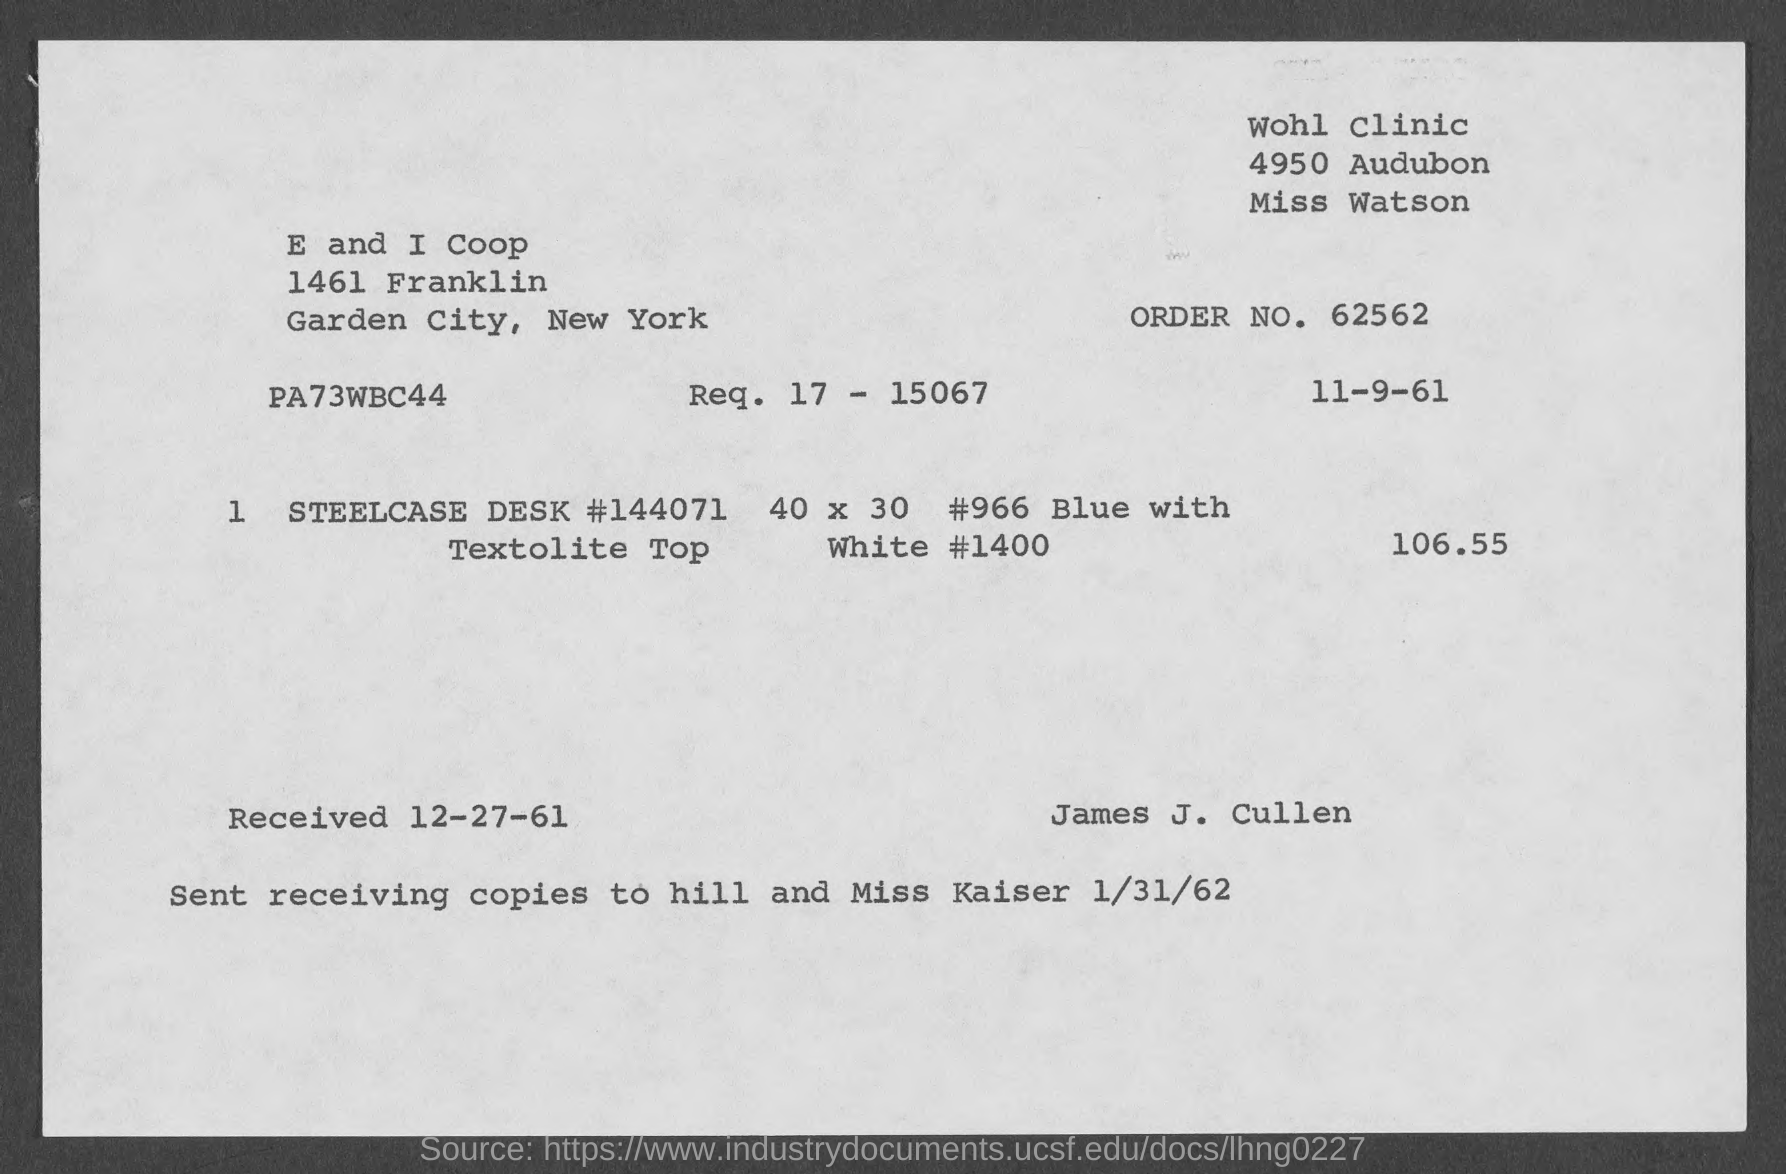What is the Order No.?
Provide a succinct answer. 62562. What is the date on the document?
Provide a short and direct response. 11-9-61. When was it received?
Provide a short and direct response. 12-27-61. Sent receiving copies to whom?
Your response must be concise. Hill and miss kaiser. 